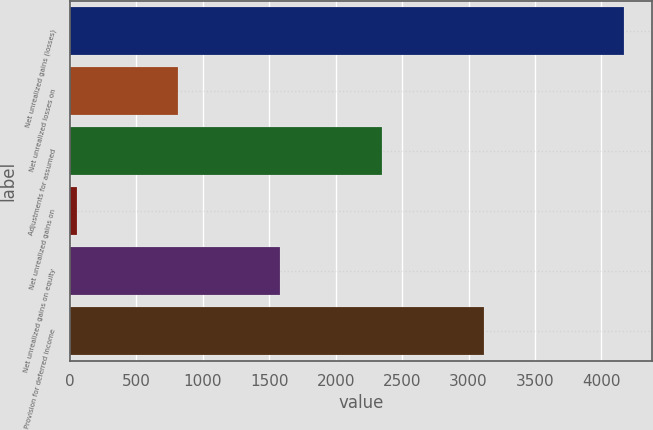<chart> <loc_0><loc_0><loc_500><loc_500><bar_chart><fcel>Net unrealized gains (losses)<fcel>Net unrealized losses on<fcel>Adjustments for assumed<fcel>Net unrealized gains on<fcel>Net unrealized gains on equity<fcel>Provision for deferred income<nl><fcel>4170.8<fcel>815.82<fcel>2347.46<fcel>50<fcel>1581.64<fcel>3113.28<nl></chart> 